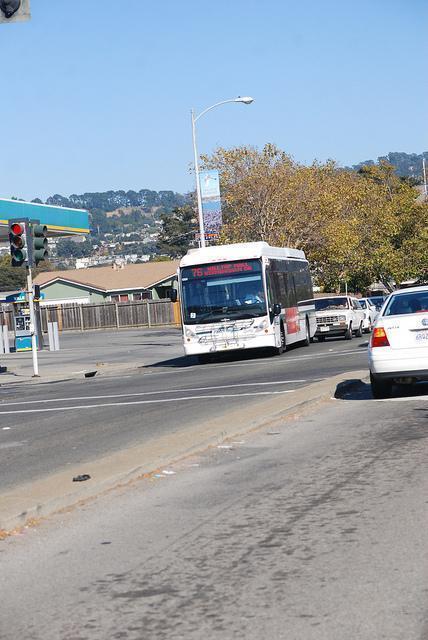Which vehicle is leading the ones on the left side?
Pick the correct solution from the four options below to address the question.
Options: Airplane, tank, bus, motorcycle. Bus. 